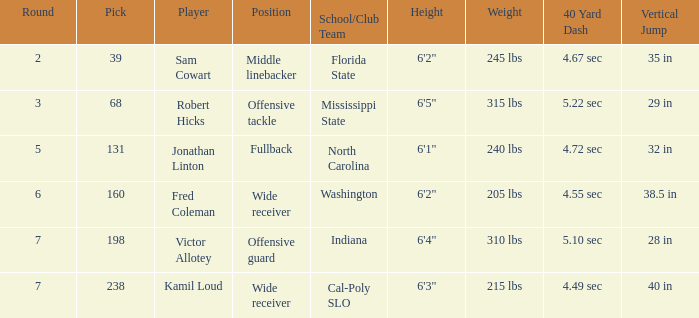Which Round has a School/Club Team of indiana, and a Pick smaller than 198? None. 